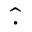<formula> <loc_0><loc_0><loc_500><loc_500>\widehat { \cdot }</formula> 